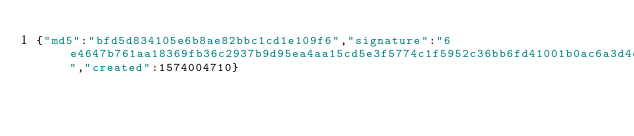<code> <loc_0><loc_0><loc_500><loc_500><_SML_>{"md5":"bfd5d834105e6b8ae82bbc1cd1e109f6","signature":"6e4647b761aa18369fb36c2937b9d95ea4aa15cd5e3f5774c1f5952c36bb6fd41001b0ac6a3d4e74ce3028023822c34d2b7d3d4fe02574b26df82da262e00d03","created":1574004710}</code> 